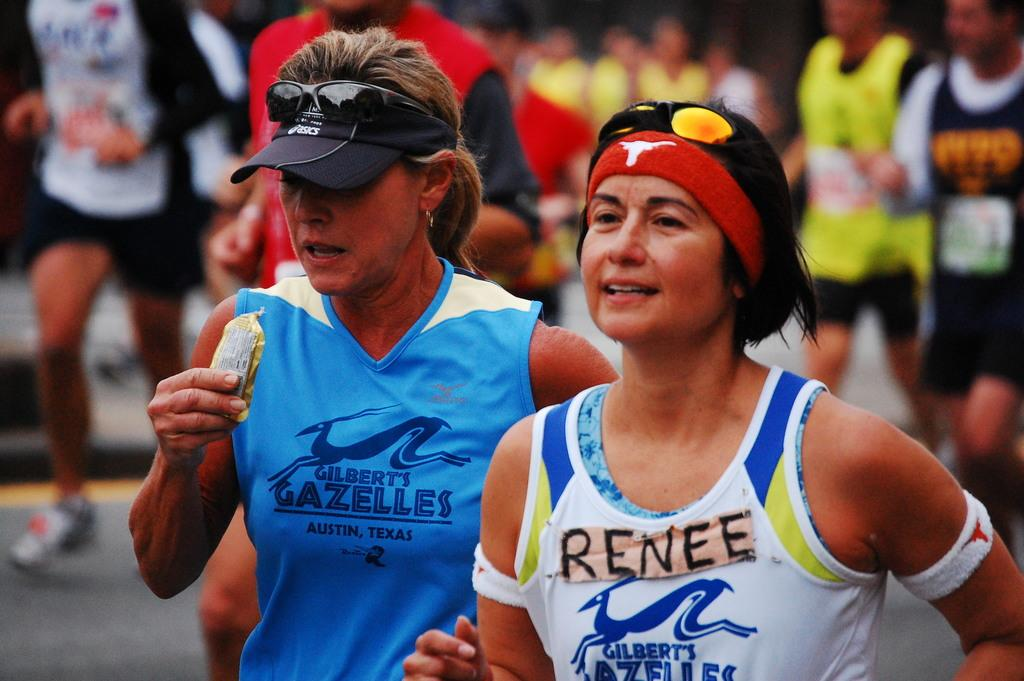<image>
Render a clear and concise summary of the photo. A girl with a head band is running with the name Renee on her shirt. 